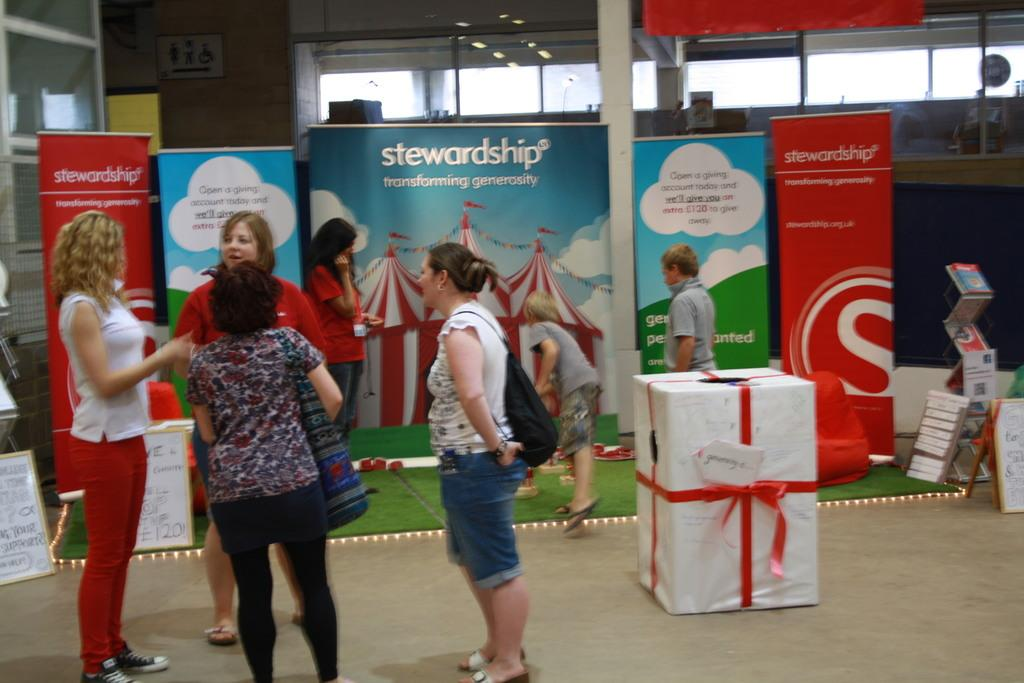<image>
Relay a brief, clear account of the picture shown. A group of women talking in front of an advert for stewardship. 